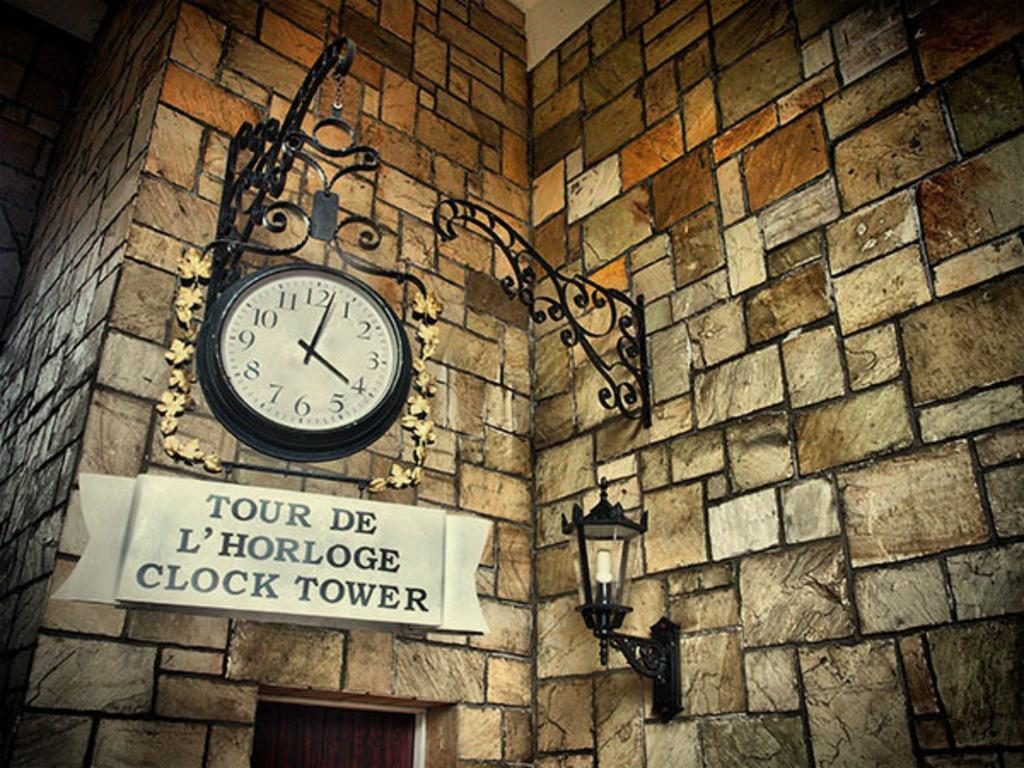Provide a one-sentence caption for the provided image. A clock with a sign underneath reading Tour De L'Horloge Clock Tower. 